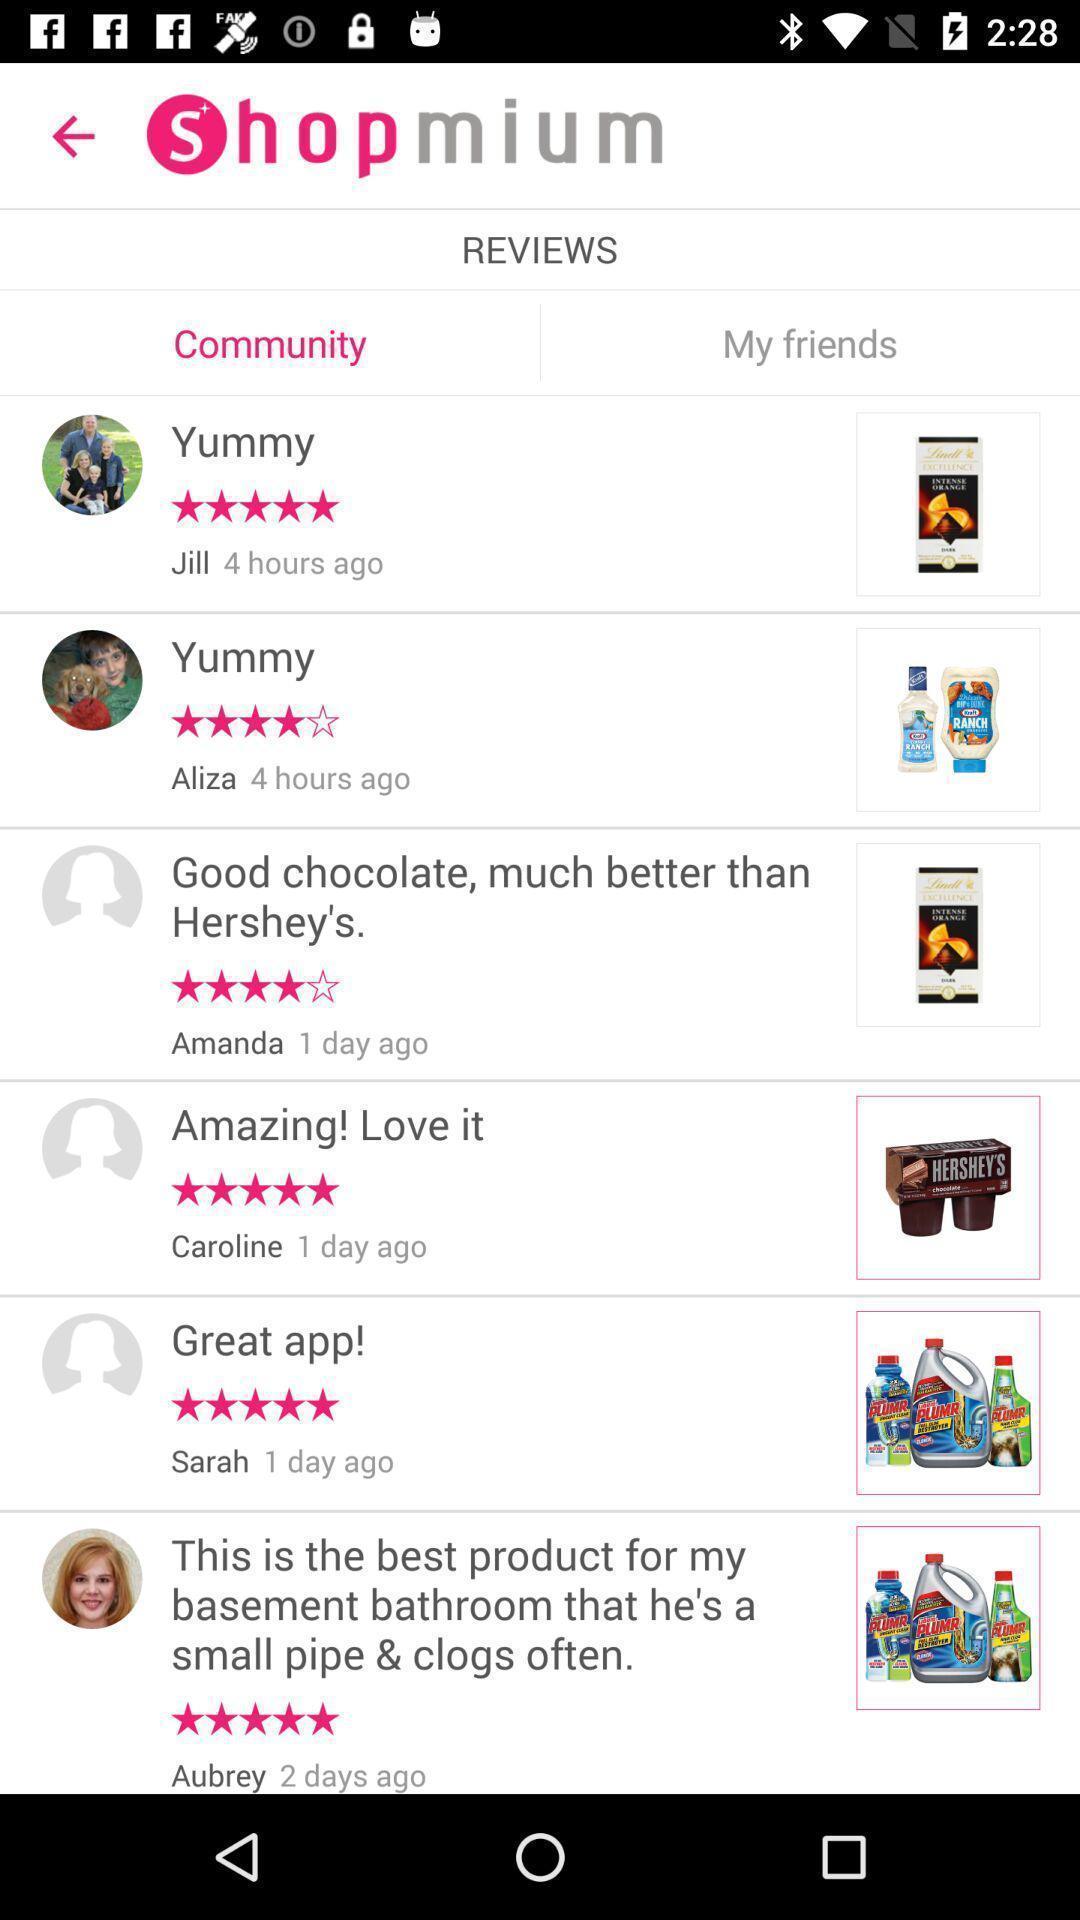Provide a description of this screenshot. Review page in a groceries app. 